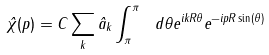Convert formula to latex. <formula><loc_0><loc_0><loc_500><loc_500>\hat { \chi } ( p ) = C \sum _ { k } \hat { a } _ { k } \int _ { \pi } ^ { \pi } \ d \theta e ^ { i k R \theta } e ^ { - i p R \sin ( \theta ) }</formula> 